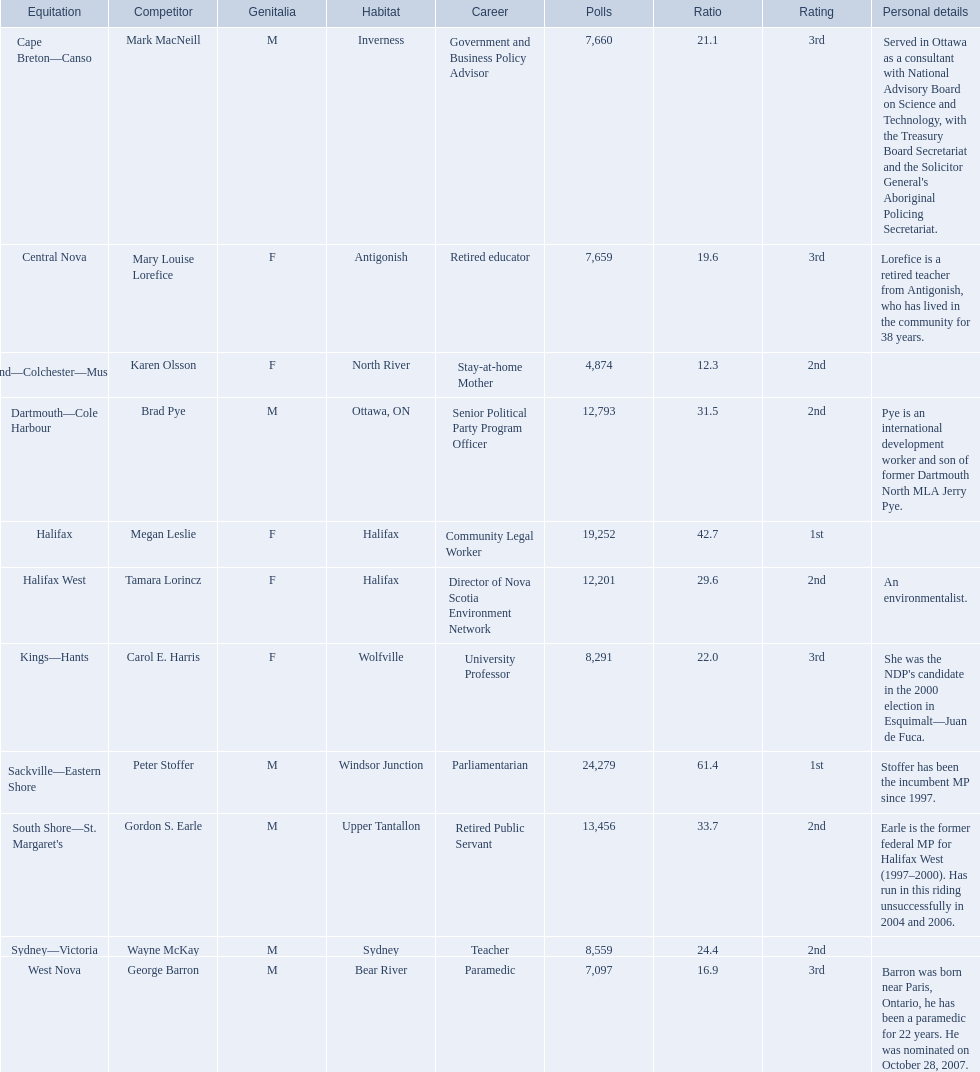Parse the full table. {'header': ['Equitation', 'Competitor', 'Genitalia', 'Habitat', 'Career', 'Polls', 'Ratio', 'Rating', 'Personal details'], 'rows': [['Cape Breton—Canso', 'Mark MacNeill', 'M', 'Inverness', 'Government and Business Policy Advisor', '7,660', '21.1', '3rd', "Served in Ottawa as a consultant with National Advisory Board on Science and Technology, with the Treasury Board Secretariat and the Solicitor General's Aboriginal Policing Secretariat."], ['Central Nova', 'Mary Louise Lorefice', 'F', 'Antigonish', 'Retired educator', '7,659', '19.6', '3rd', 'Lorefice is a retired teacher from Antigonish, who has lived in the community for 38 years.'], ['Cumberland—Colchester—Musquodoboit Valley', 'Karen Olsson', 'F', 'North River', 'Stay-at-home Mother', '4,874', '12.3', '2nd', ''], ['Dartmouth—Cole Harbour', 'Brad Pye', 'M', 'Ottawa, ON', 'Senior Political Party Program Officer', '12,793', '31.5', '2nd', 'Pye is an international development worker and son of former Dartmouth North MLA Jerry Pye.'], ['Halifax', 'Megan Leslie', 'F', 'Halifax', 'Community Legal Worker', '19,252', '42.7', '1st', ''], ['Halifax West', 'Tamara Lorincz', 'F', 'Halifax', 'Director of Nova Scotia Environment Network', '12,201', '29.6', '2nd', 'An environmentalist.'], ['Kings—Hants', 'Carol E. Harris', 'F', 'Wolfville', 'University Professor', '8,291', '22.0', '3rd', "She was the NDP's candidate in the 2000 election in Esquimalt—Juan de Fuca."], ['Sackville—Eastern Shore', 'Peter Stoffer', 'M', 'Windsor Junction', 'Parliamentarian', '24,279', '61.4', '1st', 'Stoffer has been the incumbent MP since 1997.'], ["South Shore—St. Margaret's", 'Gordon S. Earle', 'M', 'Upper Tantallon', 'Retired Public Servant', '13,456', '33.7', '2nd', 'Earle is the former federal MP for Halifax West (1997–2000). Has run in this riding unsuccessfully in 2004 and 2006.'], ['Sydney—Victoria', 'Wayne McKay', 'M', 'Sydney', 'Teacher', '8,559', '24.4', '2nd', ''], ['West Nova', 'George Barron', 'M', 'Bear River', 'Paramedic', '7,097', '16.9', '3rd', 'Barron was born near Paris, Ontario, he has been a paramedic for 22 years. He was nominated on October 28, 2007.']]} How many votes did macneill receive? 7,660. How many votes did olsoon receive? 4,874. Between macneil and olsson, who received more votes? Mark MacNeill. Who are all the candidates? Mark MacNeill, Mary Louise Lorefice, Karen Olsson, Brad Pye, Megan Leslie, Tamara Lorincz, Carol E. Harris, Peter Stoffer, Gordon S. Earle, Wayne McKay, George Barron. How many votes did they receive? 7,660, 7,659, 4,874, 12,793, 19,252, 12,201, 8,291, 24,279, 13,456, 8,559, 7,097. And of those, how many were for megan leslie? 19,252. 